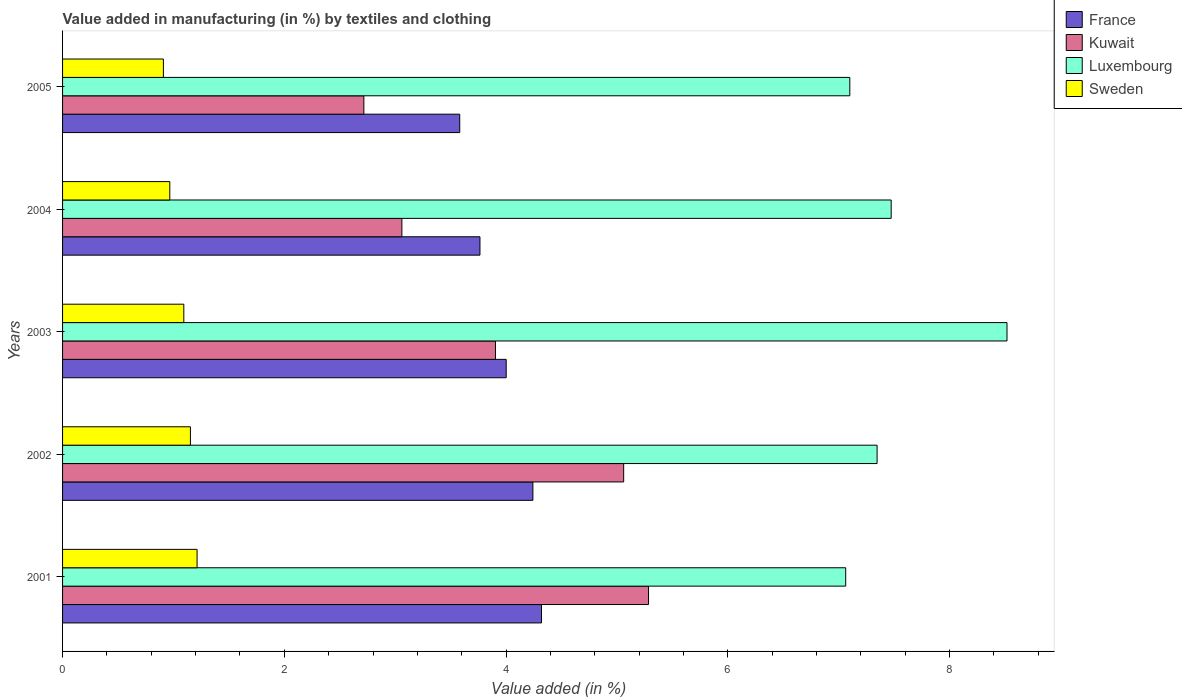What is the label of the 2nd group of bars from the top?
Ensure brevity in your answer.  2004. What is the percentage of value added in manufacturing by textiles and clothing in Sweden in 2004?
Keep it short and to the point. 0.97. Across all years, what is the maximum percentage of value added in manufacturing by textiles and clothing in Sweden?
Provide a succinct answer. 1.21. Across all years, what is the minimum percentage of value added in manufacturing by textiles and clothing in Kuwait?
Provide a succinct answer. 2.72. In which year was the percentage of value added in manufacturing by textiles and clothing in Luxembourg maximum?
Make the answer very short. 2003. In which year was the percentage of value added in manufacturing by textiles and clothing in France minimum?
Offer a very short reply. 2005. What is the total percentage of value added in manufacturing by textiles and clothing in Kuwait in the graph?
Make the answer very short. 20.03. What is the difference between the percentage of value added in manufacturing by textiles and clothing in Luxembourg in 2001 and that in 2003?
Make the answer very short. -1.45. What is the difference between the percentage of value added in manufacturing by textiles and clothing in Kuwait in 2005 and the percentage of value added in manufacturing by textiles and clothing in Sweden in 2002?
Provide a short and direct response. 1.56. What is the average percentage of value added in manufacturing by textiles and clothing in Kuwait per year?
Offer a terse response. 4.01. In the year 2002, what is the difference between the percentage of value added in manufacturing by textiles and clothing in Luxembourg and percentage of value added in manufacturing by textiles and clothing in Kuwait?
Ensure brevity in your answer.  2.29. What is the ratio of the percentage of value added in manufacturing by textiles and clothing in Sweden in 2001 to that in 2005?
Give a very brief answer. 1.33. Is the percentage of value added in manufacturing by textiles and clothing in Kuwait in 2001 less than that in 2003?
Provide a short and direct response. No. Is the difference between the percentage of value added in manufacturing by textiles and clothing in Luxembourg in 2003 and 2004 greater than the difference between the percentage of value added in manufacturing by textiles and clothing in Kuwait in 2003 and 2004?
Offer a very short reply. Yes. What is the difference between the highest and the second highest percentage of value added in manufacturing by textiles and clothing in France?
Give a very brief answer. 0.08. What is the difference between the highest and the lowest percentage of value added in manufacturing by textiles and clothing in France?
Keep it short and to the point. 0.74. Is the sum of the percentage of value added in manufacturing by textiles and clothing in Luxembourg in 2001 and 2003 greater than the maximum percentage of value added in manufacturing by textiles and clothing in Sweden across all years?
Your answer should be compact. Yes. What does the 3rd bar from the bottom in 2004 represents?
Make the answer very short. Luxembourg. How many bars are there?
Provide a succinct answer. 20. Are all the bars in the graph horizontal?
Ensure brevity in your answer.  Yes. What is the difference between two consecutive major ticks on the X-axis?
Give a very brief answer. 2. Are the values on the major ticks of X-axis written in scientific E-notation?
Give a very brief answer. No. Does the graph contain grids?
Provide a succinct answer. No. How many legend labels are there?
Your answer should be compact. 4. How are the legend labels stacked?
Provide a succinct answer. Vertical. What is the title of the graph?
Your answer should be compact. Value added in manufacturing (in %) by textiles and clothing. What is the label or title of the X-axis?
Make the answer very short. Value added (in %). What is the Value added (in %) in France in 2001?
Ensure brevity in your answer.  4.32. What is the Value added (in %) of Kuwait in 2001?
Make the answer very short. 5.28. What is the Value added (in %) in Luxembourg in 2001?
Your answer should be very brief. 7.06. What is the Value added (in %) in Sweden in 2001?
Your answer should be compact. 1.21. What is the Value added (in %) in France in 2002?
Keep it short and to the point. 4.24. What is the Value added (in %) of Kuwait in 2002?
Provide a succinct answer. 5.06. What is the Value added (in %) in Luxembourg in 2002?
Provide a short and direct response. 7.35. What is the Value added (in %) of Sweden in 2002?
Offer a terse response. 1.15. What is the Value added (in %) of France in 2003?
Your response must be concise. 4. What is the Value added (in %) in Kuwait in 2003?
Provide a short and direct response. 3.9. What is the Value added (in %) in Luxembourg in 2003?
Offer a very short reply. 8.52. What is the Value added (in %) in Sweden in 2003?
Provide a succinct answer. 1.09. What is the Value added (in %) in France in 2004?
Make the answer very short. 3.76. What is the Value added (in %) in Kuwait in 2004?
Ensure brevity in your answer.  3.06. What is the Value added (in %) in Luxembourg in 2004?
Your answer should be compact. 7.47. What is the Value added (in %) in Sweden in 2004?
Keep it short and to the point. 0.97. What is the Value added (in %) of France in 2005?
Give a very brief answer. 3.58. What is the Value added (in %) in Kuwait in 2005?
Your answer should be compact. 2.72. What is the Value added (in %) of Luxembourg in 2005?
Make the answer very short. 7.1. What is the Value added (in %) in Sweden in 2005?
Your answer should be very brief. 0.91. Across all years, what is the maximum Value added (in %) in France?
Your answer should be very brief. 4.32. Across all years, what is the maximum Value added (in %) of Kuwait?
Offer a very short reply. 5.28. Across all years, what is the maximum Value added (in %) of Luxembourg?
Give a very brief answer. 8.52. Across all years, what is the maximum Value added (in %) in Sweden?
Your answer should be very brief. 1.21. Across all years, what is the minimum Value added (in %) of France?
Your answer should be very brief. 3.58. Across all years, what is the minimum Value added (in %) in Kuwait?
Provide a short and direct response. 2.72. Across all years, what is the minimum Value added (in %) in Luxembourg?
Offer a terse response. 7.06. Across all years, what is the minimum Value added (in %) of Sweden?
Your answer should be compact. 0.91. What is the total Value added (in %) of France in the graph?
Your answer should be compact. 19.91. What is the total Value added (in %) of Kuwait in the graph?
Provide a succinct answer. 20.03. What is the total Value added (in %) in Luxembourg in the graph?
Your response must be concise. 37.5. What is the total Value added (in %) in Sweden in the graph?
Keep it short and to the point. 5.34. What is the difference between the Value added (in %) of France in 2001 and that in 2002?
Keep it short and to the point. 0.08. What is the difference between the Value added (in %) of Kuwait in 2001 and that in 2002?
Your answer should be very brief. 0.22. What is the difference between the Value added (in %) in Luxembourg in 2001 and that in 2002?
Give a very brief answer. -0.28. What is the difference between the Value added (in %) in Sweden in 2001 and that in 2002?
Provide a succinct answer. 0.06. What is the difference between the Value added (in %) of France in 2001 and that in 2003?
Ensure brevity in your answer.  0.32. What is the difference between the Value added (in %) in Kuwait in 2001 and that in 2003?
Your answer should be very brief. 1.38. What is the difference between the Value added (in %) of Luxembourg in 2001 and that in 2003?
Your answer should be very brief. -1.45. What is the difference between the Value added (in %) in Sweden in 2001 and that in 2003?
Your answer should be very brief. 0.12. What is the difference between the Value added (in %) of France in 2001 and that in 2004?
Your answer should be compact. 0.55. What is the difference between the Value added (in %) in Kuwait in 2001 and that in 2004?
Offer a very short reply. 2.22. What is the difference between the Value added (in %) in Luxembourg in 2001 and that in 2004?
Your response must be concise. -0.41. What is the difference between the Value added (in %) in Sweden in 2001 and that in 2004?
Offer a terse response. 0.25. What is the difference between the Value added (in %) of France in 2001 and that in 2005?
Your answer should be compact. 0.74. What is the difference between the Value added (in %) in Kuwait in 2001 and that in 2005?
Offer a very short reply. 2.57. What is the difference between the Value added (in %) of Luxembourg in 2001 and that in 2005?
Offer a very short reply. -0.04. What is the difference between the Value added (in %) of Sweden in 2001 and that in 2005?
Make the answer very short. 0.3. What is the difference between the Value added (in %) of France in 2002 and that in 2003?
Offer a very short reply. 0.24. What is the difference between the Value added (in %) in Kuwait in 2002 and that in 2003?
Keep it short and to the point. 1.16. What is the difference between the Value added (in %) of Luxembourg in 2002 and that in 2003?
Your response must be concise. -1.17. What is the difference between the Value added (in %) in Sweden in 2002 and that in 2003?
Ensure brevity in your answer.  0.06. What is the difference between the Value added (in %) in France in 2002 and that in 2004?
Offer a very short reply. 0.48. What is the difference between the Value added (in %) of Kuwait in 2002 and that in 2004?
Make the answer very short. 2. What is the difference between the Value added (in %) of Luxembourg in 2002 and that in 2004?
Your answer should be compact. -0.13. What is the difference between the Value added (in %) of Sweden in 2002 and that in 2004?
Keep it short and to the point. 0.19. What is the difference between the Value added (in %) in France in 2002 and that in 2005?
Your answer should be very brief. 0.66. What is the difference between the Value added (in %) in Kuwait in 2002 and that in 2005?
Provide a short and direct response. 2.34. What is the difference between the Value added (in %) of Luxembourg in 2002 and that in 2005?
Offer a very short reply. 0.25. What is the difference between the Value added (in %) of Sweden in 2002 and that in 2005?
Offer a very short reply. 0.24. What is the difference between the Value added (in %) in France in 2003 and that in 2004?
Your answer should be very brief. 0.24. What is the difference between the Value added (in %) in Kuwait in 2003 and that in 2004?
Make the answer very short. 0.84. What is the difference between the Value added (in %) of Luxembourg in 2003 and that in 2004?
Your answer should be compact. 1.04. What is the difference between the Value added (in %) of Sweden in 2003 and that in 2004?
Make the answer very short. 0.13. What is the difference between the Value added (in %) of France in 2003 and that in 2005?
Keep it short and to the point. 0.42. What is the difference between the Value added (in %) of Kuwait in 2003 and that in 2005?
Your answer should be very brief. 1.19. What is the difference between the Value added (in %) of Luxembourg in 2003 and that in 2005?
Ensure brevity in your answer.  1.42. What is the difference between the Value added (in %) in Sweden in 2003 and that in 2005?
Your response must be concise. 0.18. What is the difference between the Value added (in %) in France in 2004 and that in 2005?
Provide a short and direct response. 0.18. What is the difference between the Value added (in %) in Kuwait in 2004 and that in 2005?
Give a very brief answer. 0.34. What is the difference between the Value added (in %) in Luxembourg in 2004 and that in 2005?
Your response must be concise. 0.37. What is the difference between the Value added (in %) in Sweden in 2004 and that in 2005?
Offer a terse response. 0.06. What is the difference between the Value added (in %) of France in 2001 and the Value added (in %) of Kuwait in 2002?
Make the answer very short. -0.74. What is the difference between the Value added (in %) in France in 2001 and the Value added (in %) in Luxembourg in 2002?
Ensure brevity in your answer.  -3.03. What is the difference between the Value added (in %) in France in 2001 and the Value added (in %) in Sweden in 2002?
Ensure brevity in your answer.  3.17. What is the difference between the Value added (in %) of Kuwait in 2001 and the Value added (in %) of Luxembourg in 2002?
Provide a short and direct response. -2.06. What is the difference between the Value added (in %) of Kuwait in 2001 and the Value added (in %) of Sweden in 2002?
Offer a terse response. 4.13. What is the difference between the Value added (in %) of Luxembourg in 2001 and the Value added (in %) of Sweden in 2002?
Keep it short and to the point. 5.91. What is the difference between the Value added (in %) in France in 2001 and the Value added (in %) in Kuwait in 2003?
Give a very brief answer. 0.42. What is the difference between the Value added (in %) of France in 2001 and the Value added (in %) of Luxembourg in 2003?
Make the answer very short. -4.2. What is the difference between the Value added (in %) in France in 2001 and the Value added (in %) in Sweden in 2003?
Provide a succinct answer. 3.23. What is the difference between the Value added (in %) of Kuwait in 2001 and the Value added (in %) of Luxembourg in 2003?
Provide a succinct answer. -3.23. What is the difference between the Value added (in %) in Kuwait in 2001 and the Value added (in %) in Sweden in 2003?
Your answer should be compact. 4.19. What is the difference between the Value added (in %) of Luxembourg in 2001 and the Value added (in %) of Sweden in 2003?
Your answer should be compact. 5.97. What is the difference between the Value added (in %) in France in 2001 and the Value added (in %) in Kuwait in 2004?
Keep it short and to the point. 1.26. What is the difference between the Value added (in %) of France in 2001 and the Value added (in %) of Luxembourg in 2004?
Offer a very short reply. -3.15. What is the difference between the Value added (in %) of France in 2001 and the Value added (in %) of Sweden in 2004?
Your response must be concise. 3.35. What is the difference between the Value added (in %) in Kuwait in 2001 and the Value added (in %) in Luxembourg in 2004?
Offer a terse response. -2.19. What is the difference between the Value added (in %) in Kuwait in 2001 and the Value added (in %) in Sweden in 2004?
Provide a short and direct response. 4.32. What is the difference between the Value added (in %) in Luxembourg in 2001 and the Value added (in %) in Sweden in 2004?
Keep it short and to the point. 6.1. What is the difference between the Value added (in %) in France in 2001 and the Value added (in %) in Kuwait in 2005?
Your response must be concise. 1.6. What is the difference between the Value added (in %) of France in 2001 and the Value added (in %) of Luxembourg in 2005?
Give a very brief answer. -2.78. What is the difference between the Value added (in %) of France in 2001 and the Value added (in %) of Sweden in 2005?
Provide a short and direct response. 3.41. What is the difference between the Value added (in %) of Kuwait in 2001 and the Value added (in %) of Luxembourg in 2005?
Make the answer very short. -1.82. What is the difference between the Value added (in %) of Kuwait in 2001 and the Value added (in %) of Sweden in 2005?
Offer a terse response. 4.38. What is the difference between the Value added (in %) of Luxembourg in 2001 and the Value added (in %) of Sweden in 2005?
Offer a very short reply. 6.15. What is the difference between the Value added (in %) in France in 2002 and the Value added (in %) in Kuwait in 2003?
Your answer should be very brief. 0.34. What is the difference between the Value added (in %) of France in 2002 and the Value added (in %) of Luxembourg in 2003?
Your answer should be very brief. -4.28. What is the difference between the Value added (in %) of France in 2002 and the Value added (in %) of Sweden in 2003?
Your answer should be very brief. 3.15. What is the difference between the Value added (in %) of Kuwait in 2002 and the Value added (in %) of Luxembourg in 2003?
Your answer should be compact. -3.46. What is the difference between the Value added (in %) in Kuwait in 2002 and the Value added (in %) in Sweden in 2003?
Keep it short and to the point. 3.97. What is the difference between the Value added (in %) of Luxembourg in 2002 and the Value added (in %) of Sweden in 2003?
Your answer should be very brief. 6.25. What is the difference between the Value added (in %) in France in 2002 and the Value added (in %) in Kuwait in 2004?
Your answer should be compact. 1.18. What is the difference between the Value added (in %) of France in 2002 and the Value added (in %) of Luxembourg in 2004?
Provide a short and direct response. -3.23. What is the difference between the Value added (in %) in France in 2002 and the Value added (in %) in Sweden in 2004?
Make the answer very short. 3.27. What is the difference between the Value added (in %) of Kuwait in 2002 and the Value added (in %) of Luxembourg in 2004?
Your response must be concise. -2.41. What is the difference between the Value added (in %) of Kuwait in 2002 and the Value added (in %) of Sweden in 2004?
Your response must be concise. 4.09. What is the difference between the Value added (in %) of Luxembourg in 2002 and the Value added (in %) of Sweden in 2004?
Offer a terse response. 6.38. What is the difference between the Value added (in %) in France in 2002 and the Value added (in %) in Kuwait in 2005?
Your response must be concise. 1.52. What is the difference between the Value added (in %) in France in 2002 and the Value added (in %) in Luxembourg in 2005?
Give a very brief answer. -2.86. What is the difference between the Value added (in %) in France in 2002 and the Value added (in %) in Sweden in 2005?
Offer a terse response. 3.33. What is the difference between the Value added (in %) in Kuwait in 2002 and the Value added (in %) in Luxembourg in 2005?
Your response must be concise. -2.04. What is the difference between the Value added (in %) in Kuwait in 2002 and the Value added (in %) in Sweden in 2005?
Provide a succinct answer. 4.15. What is the difference between the Value added (in %) in Luxembourg in 2002 and the Value added (in %) in Sweden in 2005?
Give a very brief answer. 6.44. What is the difference between the Value added (in %) in France in 2003 and the Value added (in %) in Kuwait in 2004?
Provide a short and direct response. 0.94. What is the difference between the Value added (in %) of France in 2003 and the Value added (in %) of Luxembourg in 2004?
Offer a very short reply. -3.47. What is the difference between the Value added (in %) in France in 2003 and the Value added (in %) in Sweden in 2004?
Give a very brief answer. 3.03. What is the difference between the Value added (in %) in Kuwait in 2003 and the Value added (in %) in Luxembourg in 2004?
Offer a terse response. -3.57. What is the difference between the Value added (in %) in Kuwait in 2003 and the Value added (in %) in Sweden in 2004?
Your answer should be compact. 2.94. What is the difference between the Value added (in %) in Luxembourg in 2003 and the Value added (in %) in Sweden in 2004?
Provide a succinct answer. 7.55. What is the difference between the Value added (in %) in France in 2003 and the Value added (in %) in Kuwait in 2005?
Make the answer very short. 1.28. What is the difference between the Value added (in %) of France in 2003 and the Value added (in %) of Luxembourg in 2005?
Your answer should be very brief. -3.1. What is the difference between the Value added (in %) of France in 2003 and the Value added (in %) of Sweden in 2005?
Provide a succinct answer. 3.09. What is the difference between the Value added (in %) in Kuwait in 2003 and the Value added (in %) in Luxembourg in 2005?
Keep it short and to the point. -3.2. What is the difference between the Value added (in %) in Kuwait in 2003 and the Value added (in %) in Sweden in 2005?
Your answer should be very brief. 2.99. What is the difference between the Value added (in %) of Luxembourg in 2003 and the Value added (in %) of Sweden in 2005?
Offer a very short reply. 7.61. What is the difference between the Value added (in %) of France in 2004 and the Value added (in %) of Kuwait in 2005?
Provide a short and direct response. 1.05. What is the difference between the Value added (in %) in France in 2004 and the Value added (in %) in Luxembourg in 2005?
Your answer should be very brief. -3.34. What is the difference between the Value added (in %) in France in 2004 and the Value added (in %) in Sweden in 2005?
Your answer should be very brief. 2.85. What is the difference between the Value added (in %) of Kuwait in 2004 and the Value added (in %) of Luxembourg in 2005?
Your response must be concise. -4.04. What is the difference between the Value added (in %) of Kuwait in 2004 and the Value added (in %) of Sweden in 2005?
Make the answer very short. 2.15. What is the difference between the Value added (in %) of Luxembourg in 2004 and the Value added (in %) of Sweden in 2005?
Give a very brief answer. 6.56. What is the average Value added (in %) of France per year?
Your response must be concise. 3.98. What is the average Value added (in %) of Kuwait per year?
Give a very brief answer. 4.01. What is the average Value added (in %) of Luxembourg per year?
Provide a short and direct response. 7.5. What is the average Value added (in %) in Sweden per year?
Provide a short and direct response. 1.07. In the year 2001, what is the difference between the Value added (in %) of France and Value added (in %) of Kuwait?
Keep it short and to the point. -0.97. In the year 2001, what is the difference between the Value added (in %) of France and Value added (in %) of Luxembourg?
Your answer should be compact. -2.74. In the year 2001, what is the difference between the Value added (in %) of France and Value added (in %) of Sweden?
Make the answer very short. 3.11. In the year 2001, what is the difference between the Value added (in %) of Kuwait and Value added (in %) of Luxembourg?
Your response must be concise. -1.78. In the year 2001, what is the difference between the Value added (in %) of Kuwait and Value added (in %) of Sweden?
Ensure brevity in your answer.  4.07. In the year 2001, what is the difference between the Value added (in %) in Luxembourg and Value added (in %) in Sweden?
Give a very brief answer. 5.85. In the year 2002, what is the difference between the Value added (in %) in France and Value added (in %) in Kuwait?
Ensure brevity in your answer.  -0.82. In the year 2002, what is the difference between the Value added (in %) of France and Value added (in %) of Luxembourg?
Provide a short and direct response. -3.1. In the year 2002, what is the difference between the Value added (in %) of France and Value added (in %) of Sweden?
Ensure brevity in your answer.  3.09. In the year 2002, what is the difference between the Value added (in %) of Kuwait and Value added (in %) of Luxembourg?
Your response must be concise. -2.29. In the year 2002, what is the difference between the Value added (in %) in Kuwait and Value added (in %) in Sweden?
Offer a terse response. 3.91. In the year 2002, what is the difference between the Value added (in %) of Luxembourg and Value added (in %) of Sweden?
Give a very brief answer. 6.19. In the year 2003, what is the difference between the Value added (in %) of France and Value added (in %) of Kuwait?
Offer a terse response. 0.1. In the year 2003, what is the difference between the Value added (in %) of France and Value added (in %) of Luxembourg?
Your answer should be compact. -4.52. In the year 2003, what is the difference between the Value added (in %) in France and Value added (in %) in Sweden?
Make the answer very short. 2.91. In the year 2003, what is the difference between the Value added (in %) of Kuwait and Value added (in %) of Luxembourg?
Keep it short and to the point. -4.61. In the year 2003, what is the difference between the Value added (in %) in Kuwait and Value added (in %) in Sweden?
Your response must be concise. 2.81. In the year 2003, what is the difference between the Value added (in %) in Luxembourg and Value added (in %) in Sweden?
Keep it short and to the point. 7.42. In the year 2004, what is the difference between the Value added (in %) in France and Value added (in %) in Kuwait?
Offer a very short reply. 0.7. In the year 2004, what is the difference between the Value added (in %) in France and Value added (in %) in Luxembourg?
Offer a terse response. -3.71. In the year 2004, what is the difference between the Value added (in %) of France and Value added (in %) of Sweden?
Offer a very short reply. 2.8. In the year 2004, what is the difference between the Value added (in %) in Kuwait and Value added (in %) in Luxembourg?
Provide a short and direct response. -4.41. In the year 2004, what is the difference between the Value added (in %) in Kuwait and Value added (in %) in Sweden?
Make the answer very short. 2.09. In the year 2004, what is the difference between the Value added (in %) in Luxembourg and Value added (in %) in Sweden?
Ensure brevity in your answer.  6.51. In the year 2005, what is the difference between the Value added (in %) in France and Value added (in %) in Kuwait?
Your answer should be very brief. 0.86. In the year 2005, what is the difference between the Value added (in %) of France and Value added (in %) of Luxembourg?
Ensure brevity in your answer.  -3.52. In the year 2005, what is the difference between the Value added (in %) of France and Value added (in %) of Sweden?
Offer a terse response. 2.67. In the year 2005, what is the difference between the Value added (in %) in Kuwait and Value added (in %) in Luxembourg?
Offer a very short reply. -4.38. In the year 2005, what is the difference between the Value added (in %) in Kuwait and Value added (in %) in Sweden?
Your response must be concise. 1.81. In the year 2005, what is the difference between the Value added (in %) of Luxembourg and Value added (in %) of Sweden?
Your answer should be very brief. 6.19. What is the ratio of the Value added (in %) of France in 2001 to that in 2002?
Provide a short and direct response. 1.02. What is the ratio of the Value added (in %) of Kuwait in 2001 to that in 2002?
Provide a short and direct response. 1.04. What is the ratio of the Value added (in %) in Luxembourg in 2001 to that in 2002?
Your answer should be very brief. 0.96. What is the ratio of the Value added (in %) of Sweden in 2001 to that in 2002?
Keep it short and to the point. 1.05. What is the ratio of the Value added (in %) in France in 2001 to that in 2003?
Your answer should be very brief. 1.08. What is the ratio of the Value added (in %) in Kuwait in 2001 to that in 2003?
Make the answer very short. 1.35. What is the ratio of the Value added (in %) of Luxembourg in 2001 to that in 2003?
Offer a very short reply. 0.83. What is the ratio of the Value added (in %) in Sweden in 2001 to that in 2003?
Provide a short and direct response. 1.11. What is the ratio of the Value added (in %) of France in 2001 to that in 2004?
Make the answer very short. 1.15. What is the ratio of the Value added (in %) of Kuwait in 2001 to that in 2004?
Your answer should be very brief. 1.73. What is the ratio of the Value added (in %) of Luxembourg in 2001 to that in 2004?
Make the answer very short. 0.95. What is the ratio of the Value added (in %) in Sweden in 2001 to that in 2004?
Ensure brevity in your answer.  1.25. What is the ratio of the Value added (in %) of France in 2001 to that in 2005?
Offer a very short reply. 1.21. What is the ratio of the Value added (in %) of Kuwait in 2001 to that in 2005?
Provide a short and direct response. 1.94. What is the ratio of the Value added (in %) of Luxembourg in 2001 to that in 2005?
Your response must be concise. 0.99. What is the ratio of the Value added (in %) of Sweden in 2001 to that in 2005?
Your answer should be compact. 1.33. What is the ratio of the Value added (in %) of France in 2002 to that in 2003?
Make the answer very short. 1.06. What is the ratio of the Value added (in %) of Kuwait in 2002 to that in 2003?
Give a very brief answer. 1.3. What is the ratio of the Value added (in %) in Luxembourg in 2002 to that in 2003?
Offer a terse response. 0.86. What is the ratio of the Value added (in %) of Sweden in 2002 to that in 2003?
Offer a terse response. 1.05. What is the ratio of the Value added (in %) in France in 2002 to that in 2004?
Your answer should be compact. 1.13. What is the ratio of the Value added (in %) in Kuwait in 2002 to that in 2004?
Offer a very short reply. 1.65. What is the ratio of the Value added (in %) of Sweden in 2002 to that in 2004?
Offer a terse response. 1.19. What is the ratio of the Value added (in %) in France in 2002 to that in 2005?
Make the answer very short. 1.18. What is the ratio of the Value added (in %) of Kuwait in 2002 to that in 2005?
Offer a very short reply. 1.86. What is the ratio of the Value added (in %) of Luxembourg in 2002 to that in 2005?
Offer a terse response. 1.03. What is the ratio of the Value added (in %) in Sweden in 2002 to that in 2005?
Your response must be concise. 1.27. What is the ratio of the Value added (in %) of France in 2003 to that in 2004?
Your response must be concise. 1.06. What is the ratio of the Value added (in %) of Kuwait in 2003 to that in 2004?
Give a very brief answer. 1.28. What is the ratio of the Value added (in %) of Luxembourg in 2003 to that in 2004?
Your answer should be compact. 1.14. What is the ratio of the Value added (in %) in Sweden in 2003 to that in 2004?
Give a very brief answer. 1.13. What is the ratio of the Value added (in %) in France in 2003 to that in 2005?
Offer a terse response. 1.12. What is the ratio of the Value added (in %) in Kuwait in 2003 to that in 2005?
Make the answer very short. 1.44. What is the ratio of the Value added (in %) in Luxembourg in 2003 to that in 2005?
Offer a very short reply. 1.2. What is the ratio of the Value added (in %) in Sweden in 2003 to that in 2005?
Provide a short and direct response. 1.2. What is the ratio of the Value added (in %) in France in 2004 to that in 2005?
Provide a succinct answer. 1.05. What is the ratio of the Value added (in %) in Kuwait in 2004 to that in 2005?
Your response must be concise. 1.13. What is the ratio of the Value added (in %) of Luxembourg in 2004 to that in 2005?
Provide a succinct answer. 1.05. What is the ratio of the Value added (in %) in Sweden in 2004 to that in 2005?
Your answer should be very brief. 1.06. What is the difference between the highest and the second highest Value added (in %) of France?
Provide a succinct answer. 0.08. What is the difference between the highest and the second highest Value added (in %) of Kuwait?
Your answer should be compact. 0.22. What is the difference between the highest and the second highest Value added (in %) in Luxembourg?
Offer a very short reply. 1.04. What is the difference between the highest and the lowest Value added (in %) in France?
Your answer should be very brief. 0.74. What is the difference between the highest and the lowest Value added (in %) of Kuwait?
Make the answer very short. 2.57. What is the difference between the highest and the lowest Value added (in %) in Luxembourg?
Offer a very short reply. 1.45. What is the difference between the highest and the lowest Value added (in %) in Sweden?
Make the answer very short. 0.3. 